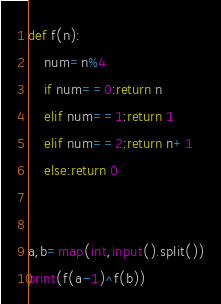<code> <loc_0><loc_0><loc_500><loc_500><_Python_>def f(n):
    num=n%4
    if num==0:return n
    elif num==1:return 1
    elif num==2:return n+1
    else:return 0


a,b=map(int,input().split())
print(f(a-1)^f(b))</code> 